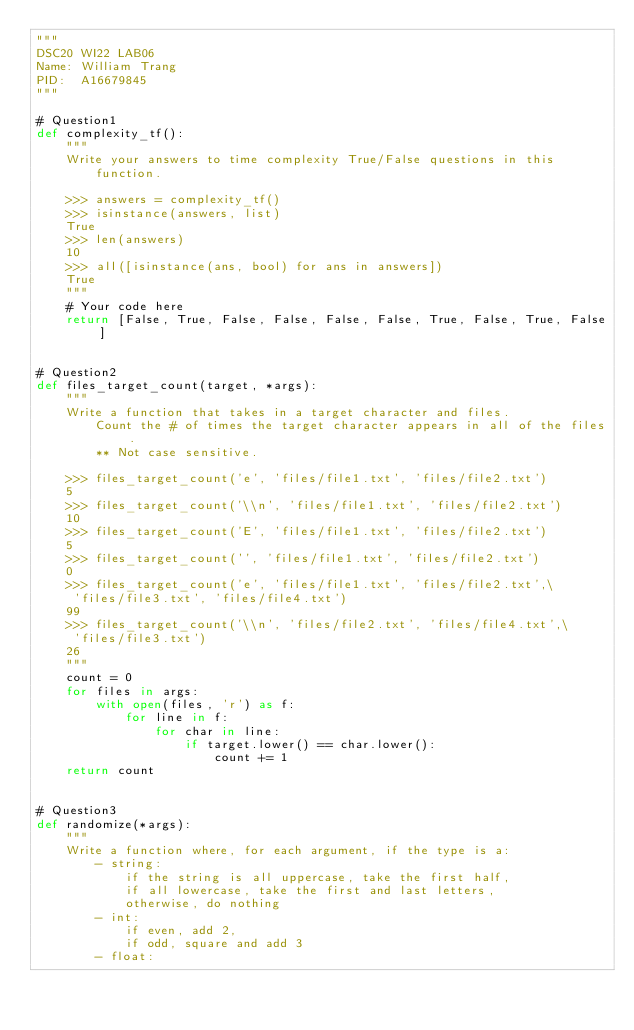<code> <loc_0><loc_0><loc_500><loc_500><_Python_>"""
DSC20 WI22 LAB06
Name: William Trang
PID:  A16679845
"""

# Question1
def complexity_tf():
    """
    Write your answers to time complexity True/False questions in this
        function.

    >>> answers = complexity_tf()
    >>> isinstance(answers, list)
    True
    >>> len(answers)
    10
    >>> all([isinstance(ans, bool) for ans in answers])
    True
    """
    # Your code here
    return [False, True, False, False, False, False, True, False, True, False]


# Question2
def files_target_count(target, *args):
    """
    Write a function that takes in a target character and files.
        Count the # of times the target character appears in all of the files.
        ** Not case sensitive.

    >>> files_target_count('e', 'files/file1.txt', 'files/file2.txt')
    5
    >>> files_target_count('\\n', 'files/file1.txt', 'files/file2.txt')
    10
    >>> files_target_count('E', 'files/file1.txt', 'files/file2.txt')
    5
    >>> files_target_count('', 'files/file1.txt', 'files/file2.txt')
    0
    >>> files_target_count('e', 'files/file1.txt', 'files/file2.txt',\
     'files/file3.txt', 'files/file4.txt')
    99
    >>> files_target_count('\\n', 'files/file2.txt', 'files/file4.txt',\
     'files/file3.txt')
    26
    """
    count = 0
    for files in args:
        with open(files, 'r') as f:
            for line in f:
                for char in line:
                    if target.lower() == char.lower():
                        count += 1
    return count


# Question3
def randomize(*args):
    """
    Write a function where, for each argument, if the type is a:
        - string:
            if the string is all uppercase, take the first half,
            if all lowercase, take the first and last letters,
            otherwise, do nothing
        - int:
            if even, add 2,
            if odd, square and add 3
        - float:</code> 